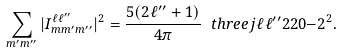<formula> <loc_0><loc_0><loc_500><loc_500>\sum _ { m ^ { \prime } m ^ { \prime \prime } } | I ^ { \ell \ell ^ { \prime \prime } } _ { m m ^ { \prime } m ^ { \prime \prime } } | ^ { 2 } = \frac { 5 ( 2 \ell ^ { \prime \prime } + 1 ) } { 4 \pi } \ t h r e e j { \ell } { \ell ^ { \prime \prime } } { 2 } { 2 } { 0 } { - 2 } ^ { 2 } .</formula> 